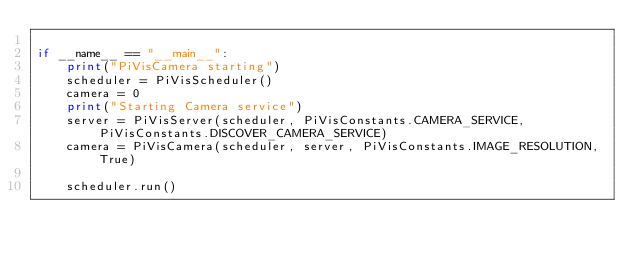<code> <loc_0><loc_0><loc_500><loc_500><_Python_>
if __name__ == "__main__":
    print("PiVisCamera starting")
    scheduler = PiVisScheduler()
    camera = 0
    print("Starting Camera service")
    server = PiVisServer(scheduler, PiVisConstants.CAMERA_SERVICE, PiVisConstants.DISCOVER_CAMERA_SERVICE)
    camera = PiVisCamera(scheduler, server, PiVisConstants.IMAGE_RESOLUTION, True)

    scheduler.run()
</code> 